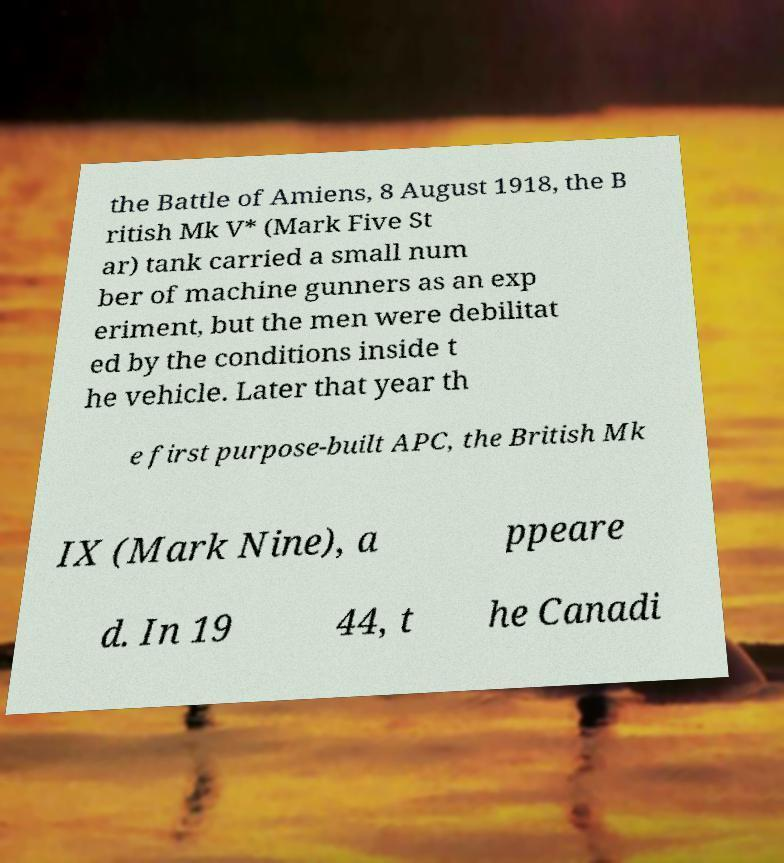Could you assist in decoding the text presented in this image and type it out clearly? the Battle of Amiens, 8 August 1918, the B ritish Mk V* (Mark Five St ar) tank carried a small num ber of machine gunners as an exp eriment, but the men were debilitat ed by the conditions inside t he vehicle. Later that year th e first purpose-built APC, the British Mk IX (Mark Nine), a ppeare d. In 19 44, t he Canadi 